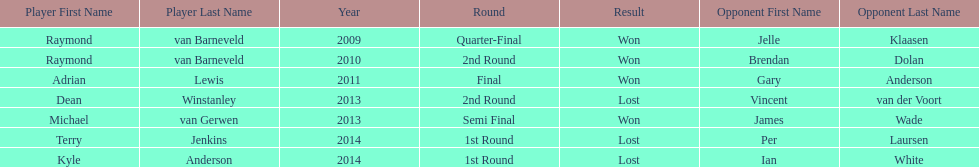Who was the last to win against his opponent? Michael van Gerwen. 